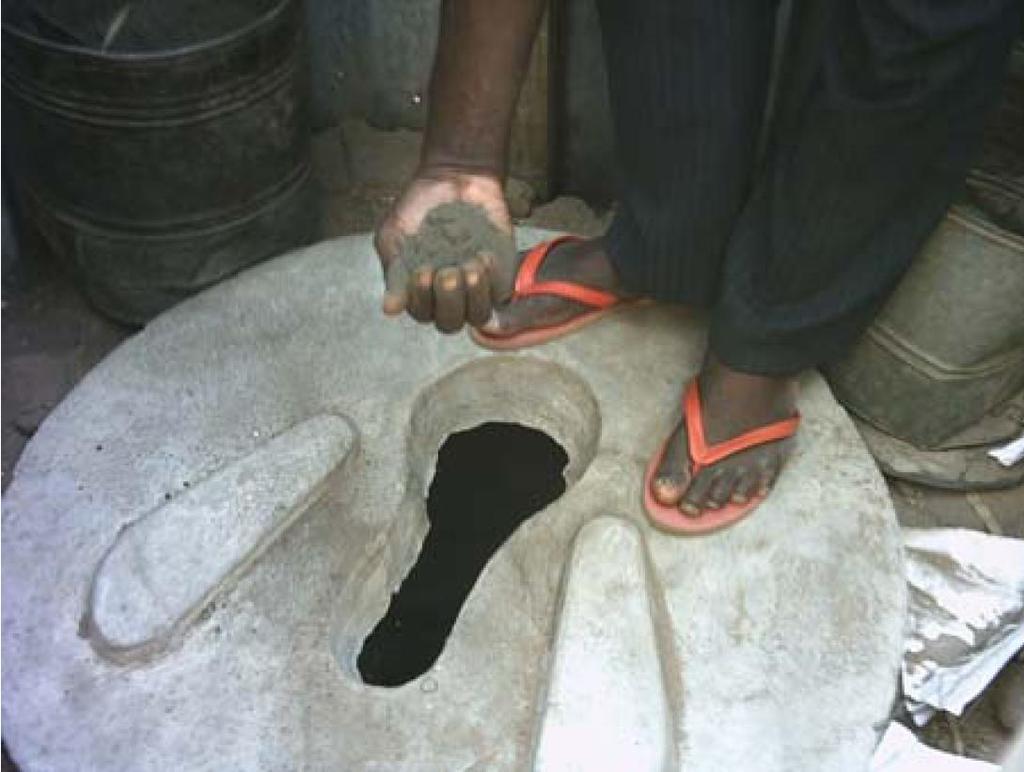In one or two sentences, can you explain what this image depicts? In this image in the center there is a commode there is a man standing and holding sand in his hand and there are objects which looks like drums. On the right side there is an object which is white in colour. 